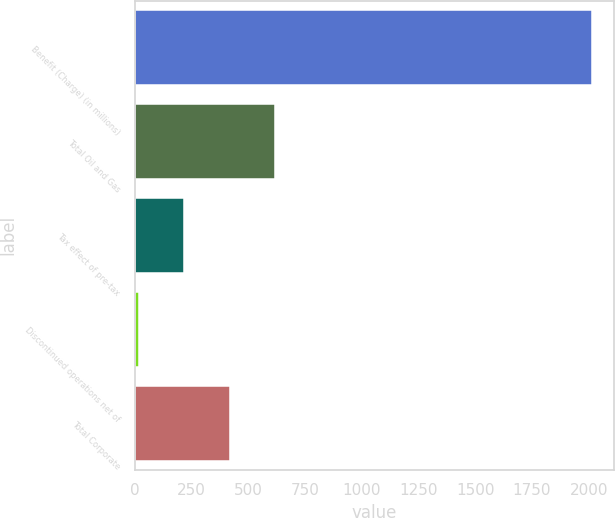Convert chart to OTSL. <chart><loc_0><loc_0><loc_500><loc_500><bar_chart><fcel>Benefit (Charge) (in millions)<fcel>Total Oil and Gas<fcel>Tax effect of pre-tax<fcel>Discontinued operations net of<fcel>Total Corporate<nl><fcel>2013<fcel>617.2<fcel>218.4<fcel>19<fcel>417.8<nl></chart> 